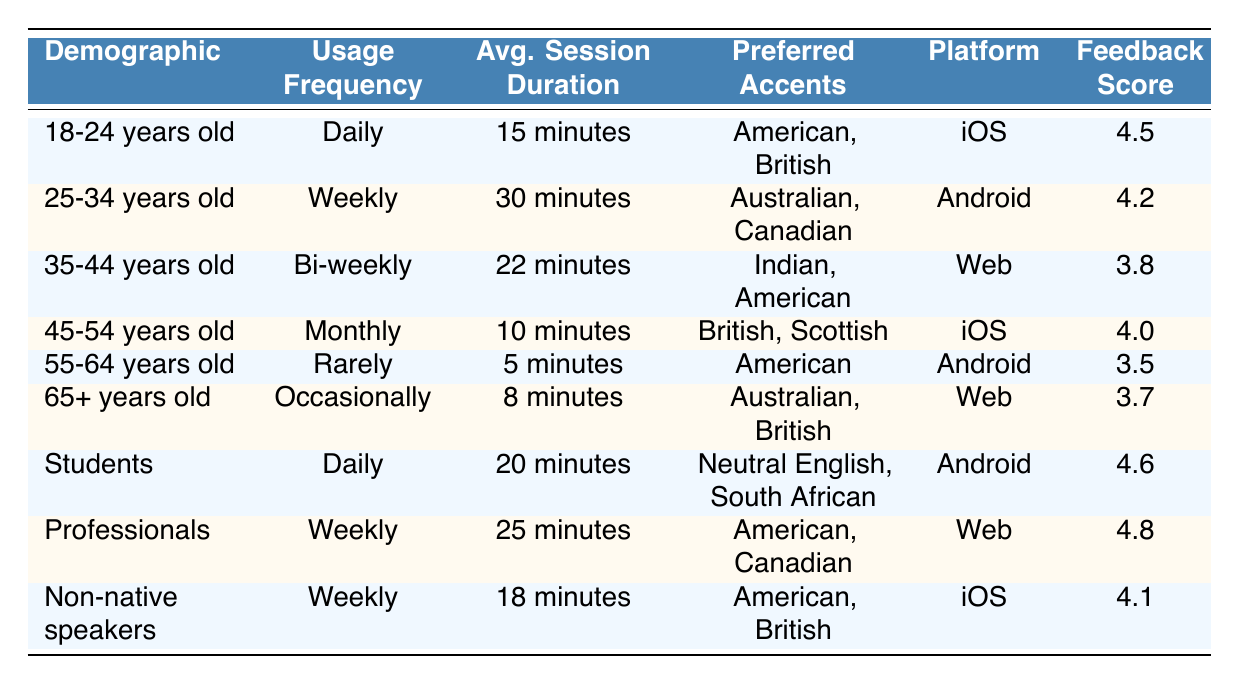What is the user feedback score for the "18-24 years old" demographic? The table shows that the user feedback score for the "18-24 years old" demographic is listed as 4.5.
Answer: 4.5 Which demographic group has the longest average session duration? By comparing the average session durations for all demographic groups, the "25-34 years old" group has the longest average session duration of 30 minutes.
Answer: 25-34 years old How many demographic groups prefer the "American" accent? The table lists three demographic groups that prefer the "American" accent: "18-24 years old," "35-44 years old," and "Non-native speakers."
Answer: 3 Is the usage frequency for "55-64 years old" demographic monthly? Yes, the table indicates that the usage frequency for the "55-64 years old" demographic is monthly.
Answer: Yes What is the average session duration for users aged 65 and above? The session duration for the "65+ years old" demographic is noted in the table as 8 minutes.
Answer: 8 minutes Which demographic group has the highest user feedback score? Upon reviewing the user feedback scores, the "Professionals" demographic has the highest score of 4.8.
Answer: Professionals What is the total average session duration of the "Students" and "Professionals" demographic groups combined? For "Students," the average session duration is 20 minutes, and for "Professionals," it’s 25 minutes. Combining these gives: 20 + 25 = 45 minutes total.
Answer: 45 minutes Do all demographic groups prefer at least one accent? Yes, according to the table, all demographic groups listed have preferred accents specified beside them.
Answer: Yes Which platform is most commonly used by users aged 45-54 years? The platform used by the "45-54 years old" demographic is specified as iOS in the table.
Answer: iOS What is the difference in user feedback scores between the "Professionals" and "55-64 years old" demographic groups? The user feedback score for "Professionals" is 4.8 while it is 3.5 for "55-64 years old." The difference is 4.8 - 3.5 = 1.3.
Answer: 1.3 